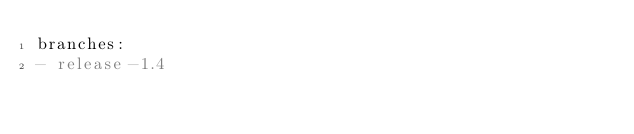Convert code to text. <code><loc_0><loc_0><loc_500><loc_500><_YAML_>branches:
- release-1.4</code> 